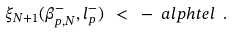Convert formula to latex. <formula><loc_0><loc_0><loc_500><loc_500>\xi _ { N + 1 } ( \beta ^ { - } _ { p , N } , l ^ { - } _ { p } ) \ < \ - \ a l p h t e l \ .</formula> 